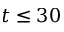Convert formula to latex. <formula><loc_0><loc_0><loc_500><loc_500>t \leq 3 0</formula> 